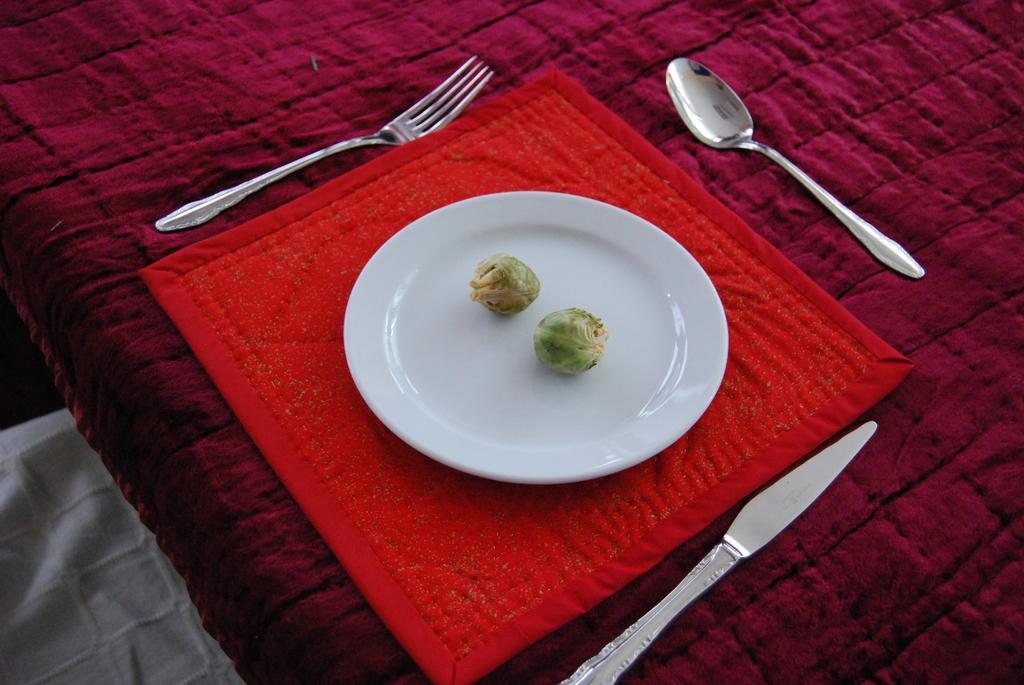Can you describe this image briefly? In the middle of the image there is a plate with two vegetables on it. The plate is placed on the red cloth. There is a fork, a knife and a spoon on the table runner. At the left bottom of the image there is a cloth which is white in color. 